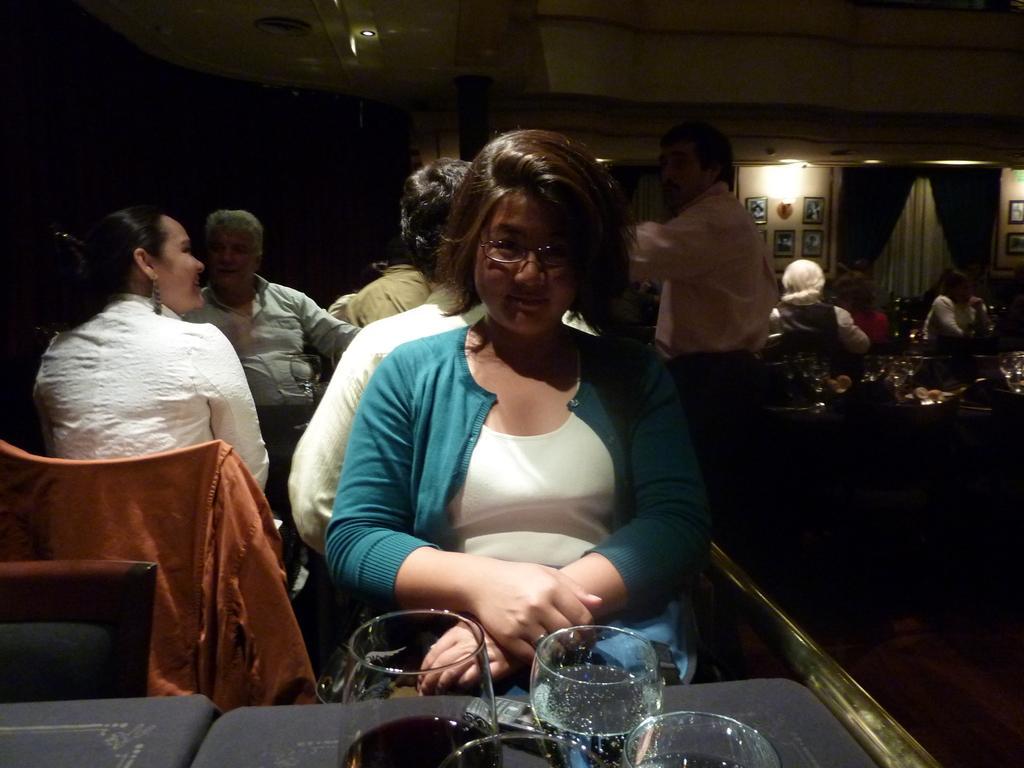Could you give a brief overview of what you see in this image? In the foreground of the image we can see a person wearing dress and spectacles is sitting on the chair near the table where glasses with drinks in it are placed. In the background, we can see a few more people sitting on the chairs near the table. The background of the image is dark, where we can see the photo frame, we can see the ceiling lights and curtains. 